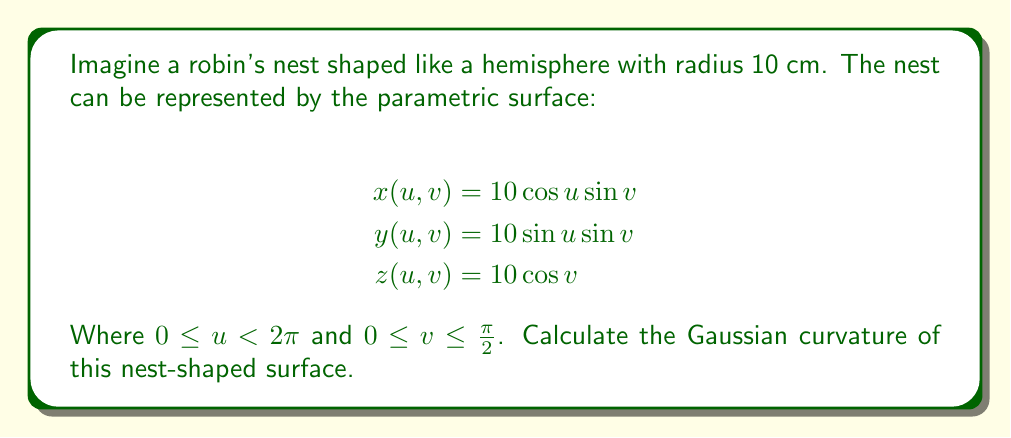What is the answer to this math problem? To find the Gaussian curvature, we need to follow these steps:

1) First, calculate the partial derivatives:
   $$x_u = -10\sin u \sin v, \quad x_v = 10\cos u \cos v$$
   $$y_u = 10\cos u \sin v, \quad y_v = 10\sin u \cos v$$
   $$z_u = 0, \quad z_v = -10\sin v$$

2) Now, calculate the coefficients of the first fundamental form:
   $$E = x_u^2 + y_u^2 + z_u^2 = 100\sin^2 v$$
   $$F = x_u x_v + y_u y_v + z_u z_v = 0$$
   $$G = x_v^2 + y_v^2 + z_v^2 = 100$$

3) Calculate the second partial derivatives:
   $$x_{uu} = -10\cos u \sin v, \quad x_{uv} = -10\sin u \cos v, \quad x_{vv} = -10\cos u \sin v$$
   $$y_{uu} = -10\sin u \sin v, \quad y_{uv} = 10\cos u \cos v, \quad y_{vv} = -10\sin u \sin v$$
   $$z_{uu} = 0, \quad z_{uv} = 0, \quad z_{vv} = -10\cos v$$

4) Calculate the coefficients of the second fundamental form:
   $$L = \frac{x_{uu}x_v + y_{uu}y_v + z_{uu}z_v}{\sqrt{EG-F^2}} = 10$$
   $$M = \frac{x_{uv}x_v + y_{uv}y_v + z_{uv}z_v}{\sqrt{EG-F^2}} = 0$$
   $$N = \frac{x_{vv}x_v + y_{vv}y_v + z_{vv}z_v}{\sqrt{EG-F^2}} = 10$$

5) The Gaussian curvature K is given by:
   $$K = \frac{LN - M^2}{EG - F^2} = \frac{10 \cdot 10 - 0^2}{100\sin^2 v \cdot 100 - 0^2} = \frac{1}{100}$$

Therefore, the Gaussian curvature of the nest-shaped surface is a constant $\frac{1}{100}$ cm^(-2).
Answer: $K = \frac{1}{100}$ cm^(-2) 